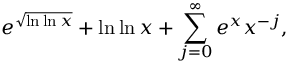<formula> <loc_0><loc_0><loc_500><loc_500>e ^ { \sqrt { \ln \ln x } } + \ln \ln x + \sum _ { j = 0 } ^ { \infty } e ^ { x } x ^ { - j } ,</formula> 